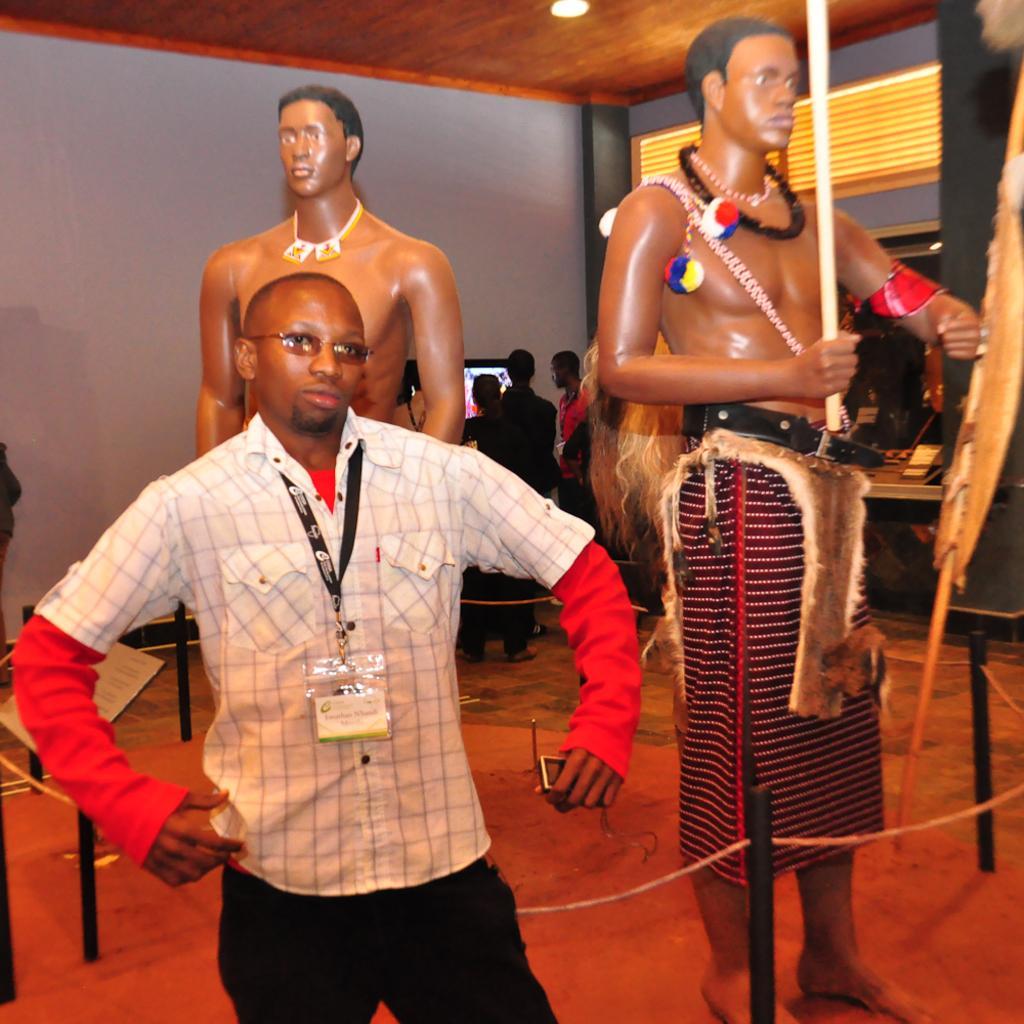Describe this image in one or two sentences. In this image in front there is a person. Behind him there is a fence. There are depictions of people. In the background of the image there are people standing in front of the TV. There is a wall. On top of the image there are lights. At the bottom of the image there is a mat. 